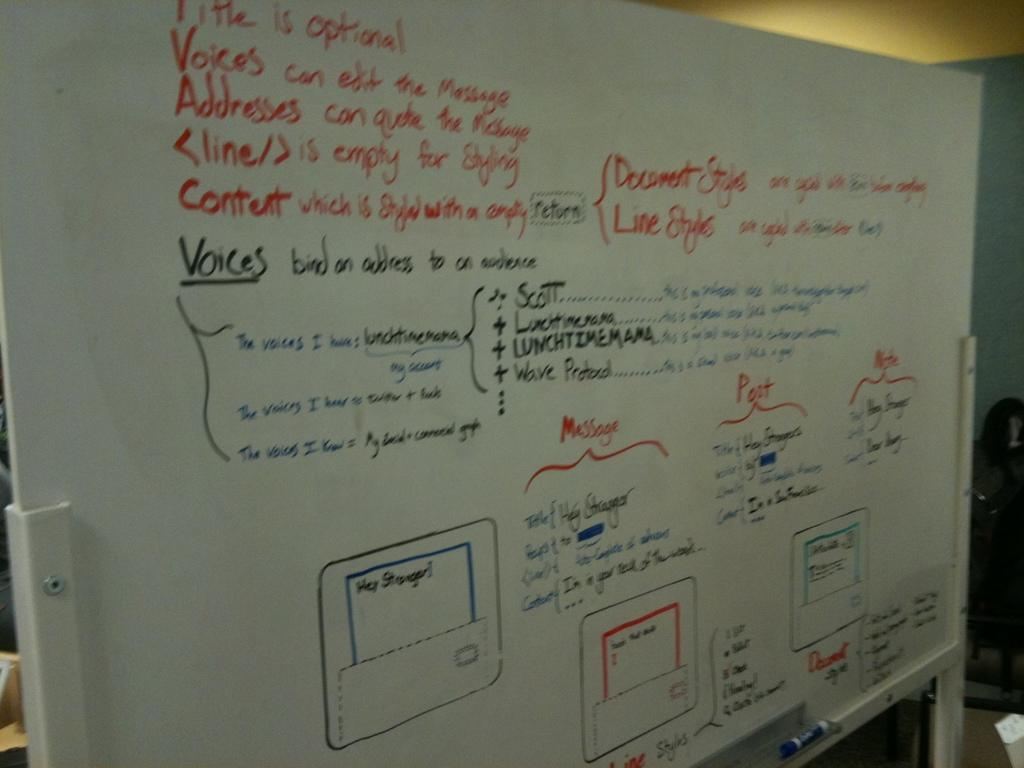Provide a one-sentence caption for the provided image. The white board has a flowchart for sending messages and instructions on styling. 